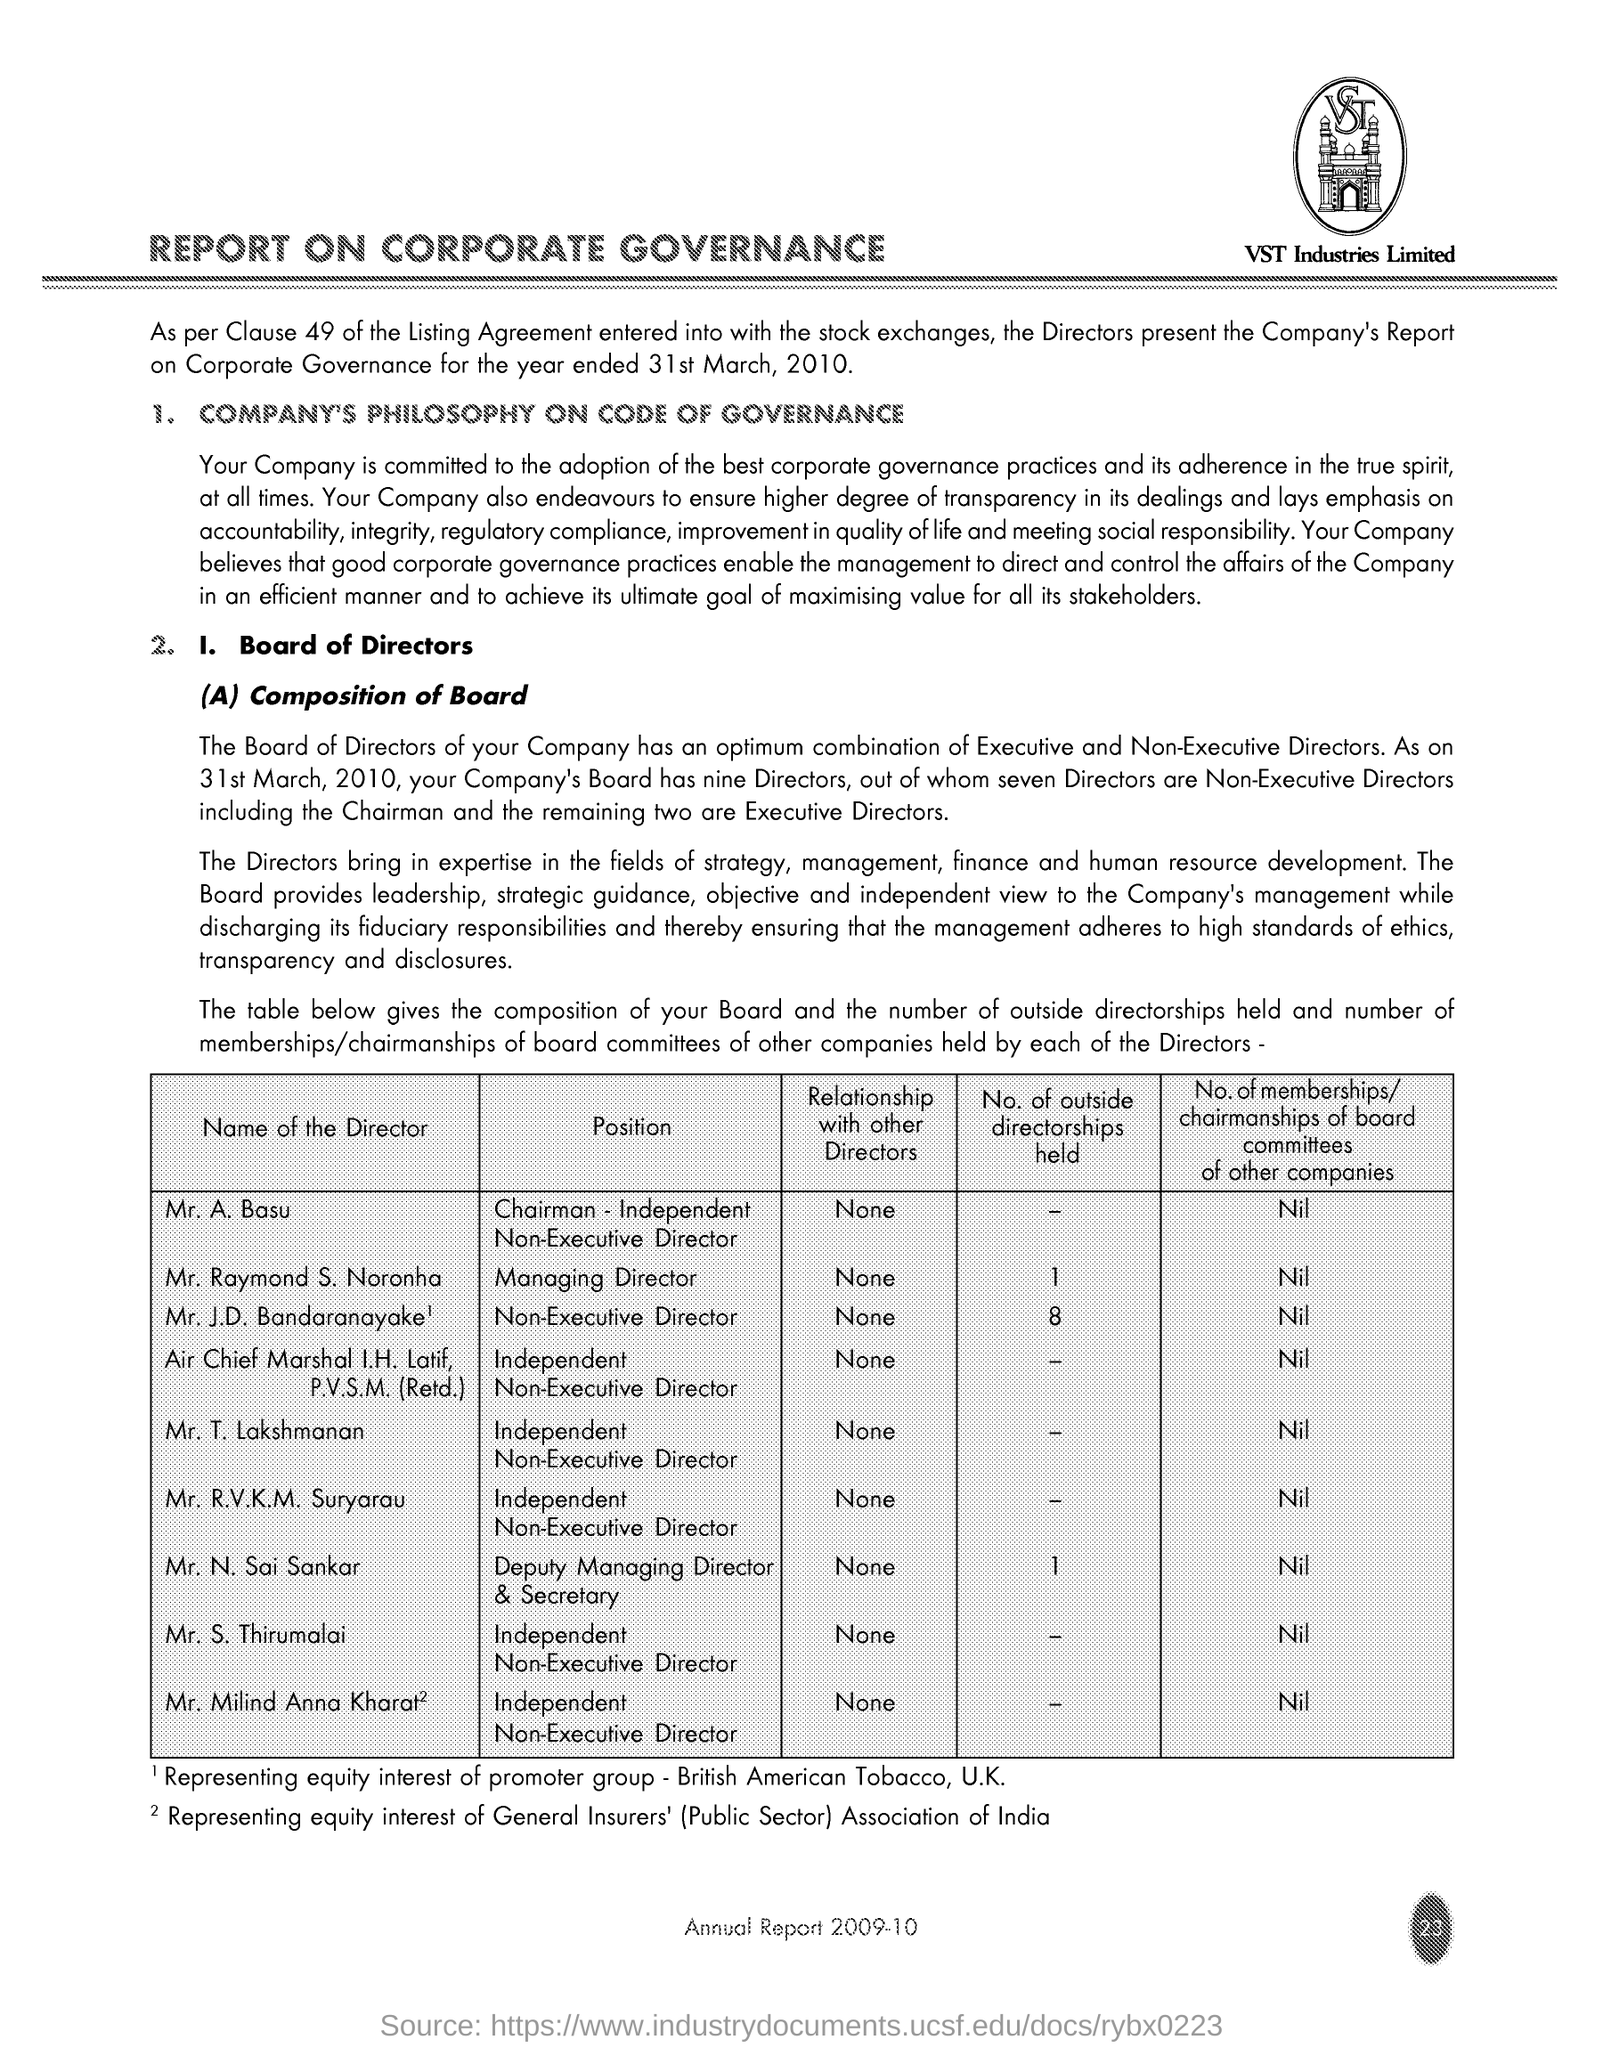What is the Company Name ?
Provide a succinct answer. VST Industries Limited. What is the Title of the document ?
Your answer should be very brief. REPORT ON CORPORATE GOVERNANCE. 